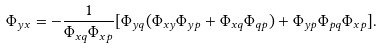Convert formula to latex. <formula><loc_0><loc_0><loc_500><loc_500>\Phi _ { y x } = - \frac { 1 } { \Phi _ { x q } \Phi _ { x p } } [ \Phi _ { y q } ( \Phi _ { x y } \Phi _ { y p } + \Phi _ { x q } \Phi _ { q p } ) + \Phi _ { y p } \Phi _ { p q } \Phi _ { x p } ] .</formula> 